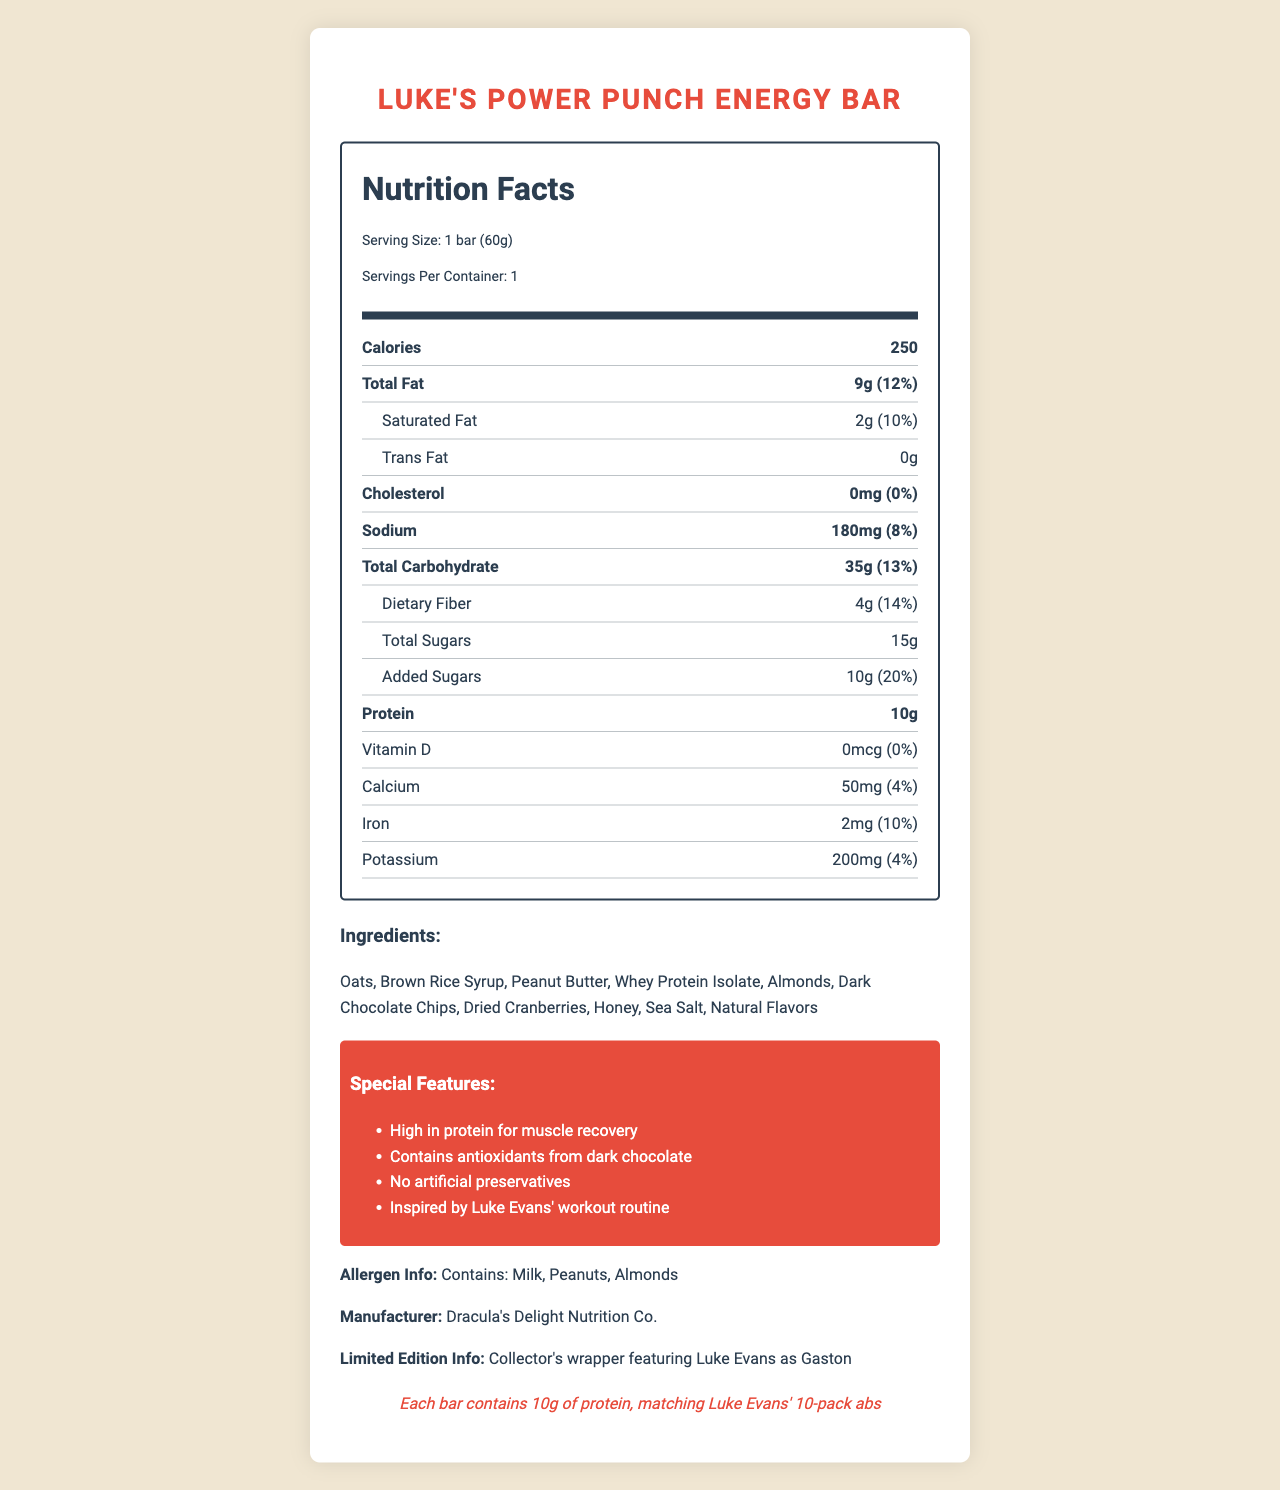What is the serving size for Luke's Power Punch Energy Bar? The document states the serving size as "1 bar (60g)" under the Nutrition Facts.
Answer: 1 bar (60g) How many calories are in one serving of Luke's Power Punch Energy Bar? The document lists the calorie content as 250 for one serving.
Answer: 250 What percentage of the daily value for saturated fat does one bar provide? The document shows the saturated fat content as 2g, with a daily value of 10%.
Answer: 10% What is the total carbohydrate content in Luke's Power Punch Energy Bar? The document lists the total carbohydrate content as 35g.
Answer: 35g Which allergen is NOT listed in the allergen info? A. Milk B. Peanuts C. Soy D. Almonds The allergen information only mentions Milk, Peanuts, and Almonds, but not Soy.
Answer: C. Soy What company manufactures Luke's Power Punch Energy Bar? The document states that the manufacturer is Dracula's Delight Nutrition Co.
Answer: Dracula's Delight Nutrition Co. Is there any cholesterol in Luke's Power Punch Energy Bar? The document states that there is 0mg of cholesterol, which equates to a 0% daily value.
Answer: No What special ingredient contributes to muscle recovery according to the special features? The special features mention "High in protein for muscle recovery," and whey protein isolate is an ingredient.
Answer: Whey Protein Isolate What inspired the creation of Luke's Power Punch Energy Bar? A. Luke Evans' workout routine B. A popular movie role C. General health trends D. Customer demand The special features section indicates that the bar was "Inspired by Luke Evans' workout routine."
Answer: A. Luke Evans' workout routine Does the energy bar contain dark chocolate chips? The document lists "Dark Chocolate Chips" as one of the ingredients.
Answer: Yes How much iron does one bar provide? The document shows that one bar contains 2mg of iron.
Answer: 2mg Give a brief summary of the document. This summary includes information from various sections of the document like the Nutrition Facts, ingredients, special features, and additional trivia about the product.
Answer: The document is a detailed Nutrition Facts Label for a limited edition Luke Evans-themed energy bar called Luke's Power Punch Energy Bar. It outlines the serving size, nutrient content, ingredients, allergen information, special features, manufacturer, limited edition info, and a fun fan trivia about Luke Evans. How much added sugar is there in one serving? The document specifies that the bar contains 10g of added sugars.
Answer: 10g Which nutrient is NOT provided in the bar according to the daily value percentages? A. Calcium B. Iron C. Vitamin D D. Potassium The document lists Vitamin D as 0mcg with a 0% daily value.
Answer: C. Vitamin D What fun fact is mentioned about Luke Evans in the document? The fan trivia section mentions this fun fact related to Luke Evans.
Answer: Each bar contains 10g of protein, matching Luke Evans' 10-pack abs How many grams of dietary fiber are in one bar? The dietary fiber content is listed as 4g in the document.
Answer: 4g What is the amount of sodium in Luke's Power Punch Energy Bar? The document states that one bar contains 180mg of sodium.
Answer: 180mg Can I determine the retail price of the energy bar from the document? The document does not provide any data related to the retail price of the energy bar.
Answer: Not enough information What are the unique features of Luke's Power Punch Energy Bar as listed in the document? The special features section outlines these unique attributes of the energy bar.
Answer: High in protein for muscle recovery, Contains antioxidants from dark chocolate, No artificial preservatives, Inspired by Luke Evans' workout routine 